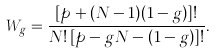<formula> <loc_0><loc_0><loc_500><loc_500>W _ { g } = \frac { [ p + ( N - 1 ) ( 1 - g ) ] ! } { N ! \, [ p - g N - ( 1 - g ) ] ! } .</formula> 